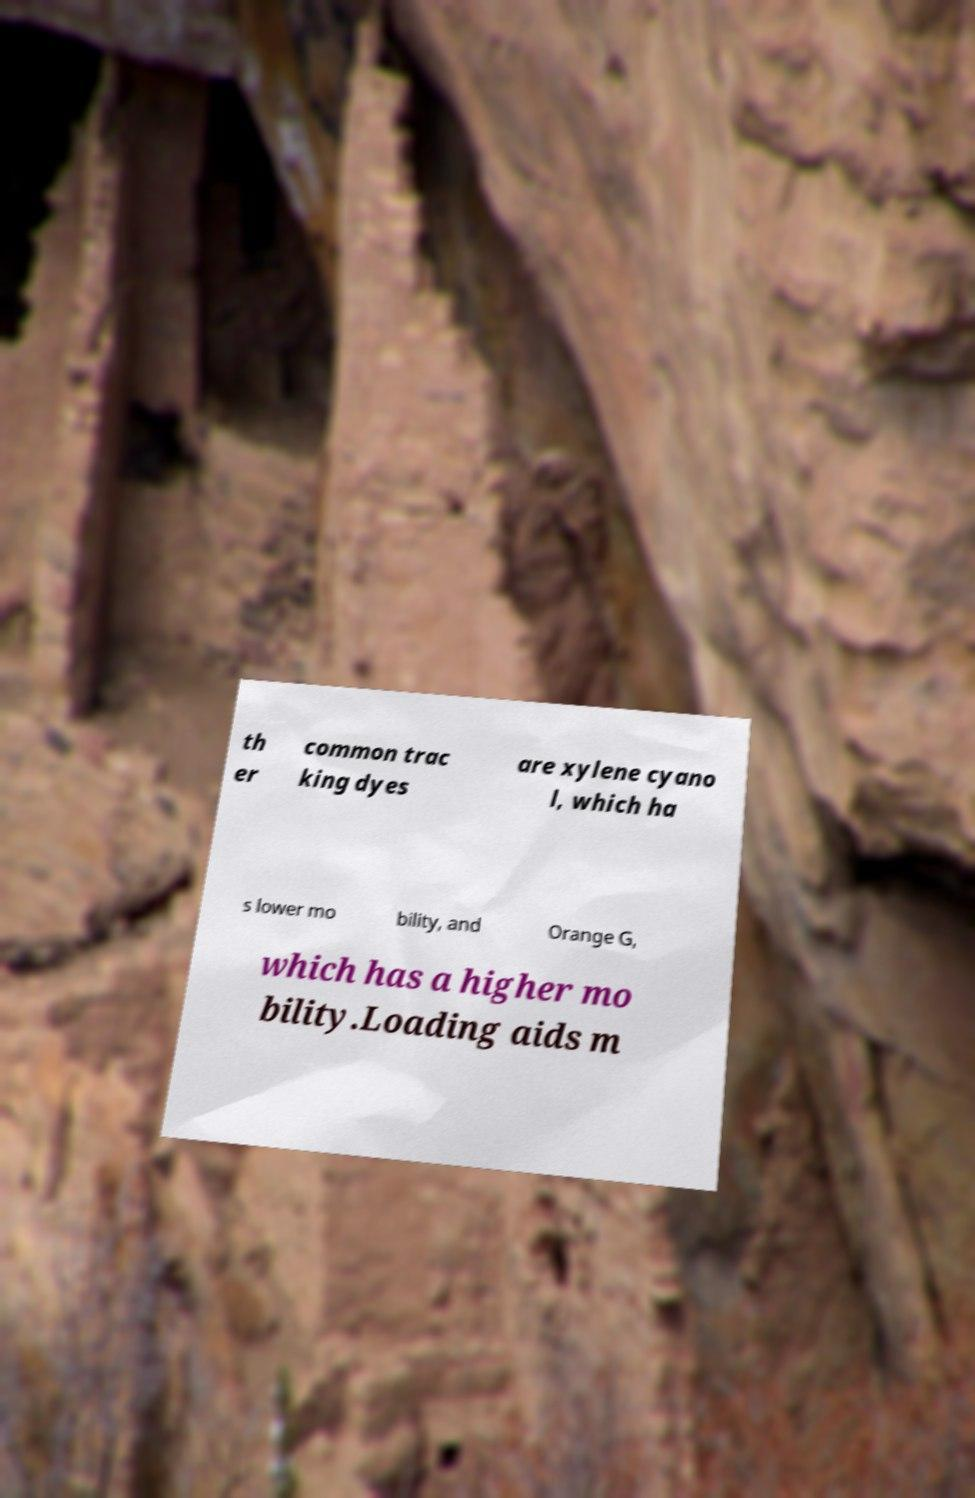For documentation purposes, I need the text within this image transcribed. Could you provide that? th er common trac king dyes are xylene cyano l, which ha s lower mo bility, and Orange G, which has a higher mo bility.Loading aids m 